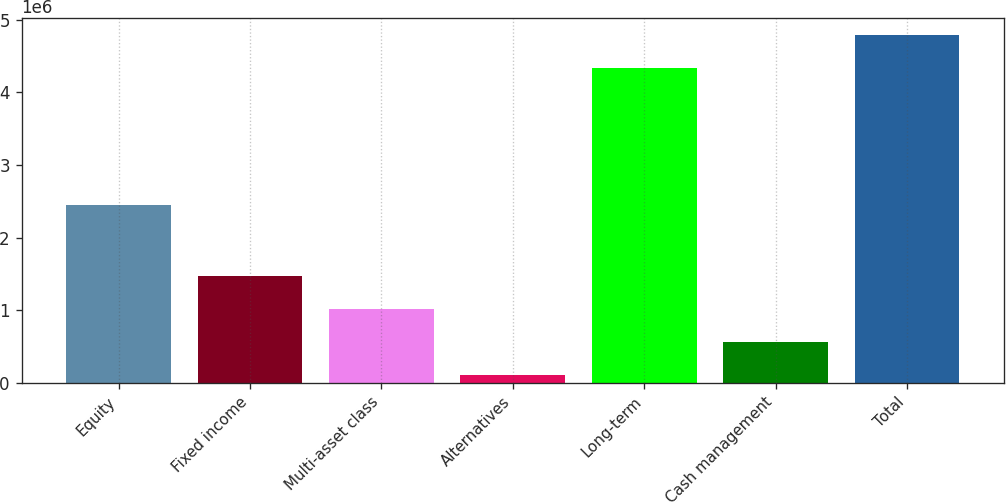<chart> <loc_0><loc_0><loc_500><loc_500><bar_chart><fcel>Equity<fcel>Fixed income<fcel>Multi-asset class<fcel>Alternatives<fcel>Long-term<fcel>Cash management<fcel>Total<nl><fcel>2.45111e+06<fcel>1.47344e+06<fcel>1.01937e+06<fcel>111240<fcel>4.33384e+06<fcel>565306<fcel>4.78791e+06<nl></chart> 